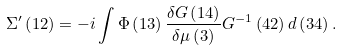Convert formula to latex. <formula><loc_0><loc_0><loc_500><loc_500>\Sigma ^ { \prime } \left ( 1 2 \right ) = - i \int \Phi \left ( 1 3 \right ) \frac { \delta G \left ( 1 4 \right ) } { \delta \mu \left ( 3 \right ) } G ^ { - 1 } \left ( 4 2 \right ) d \left ( 3 4 \right ) .</formula> 